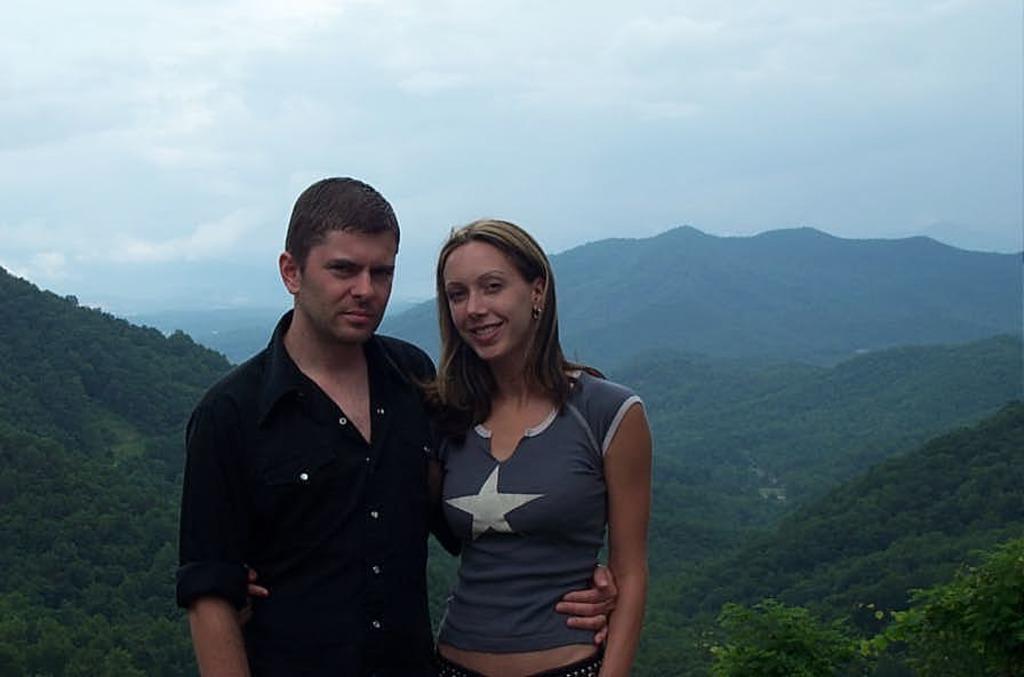Please provide a concise description of this image. In the middle of this image, there is a person in black color shirt, smiling, standing and holding the woman who is smiling and standing. In the background, there are mountains and there are clouds in the sky. 